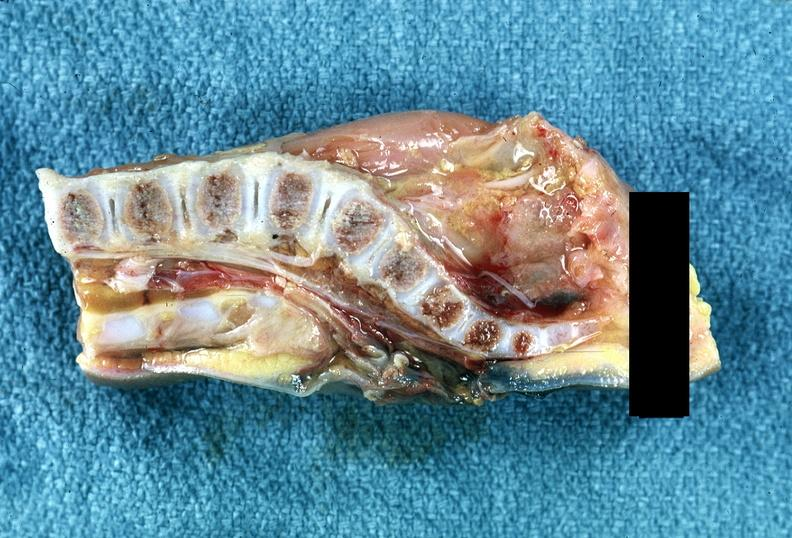s nervous present?
Answer the question using a single word or phrase. Yes 